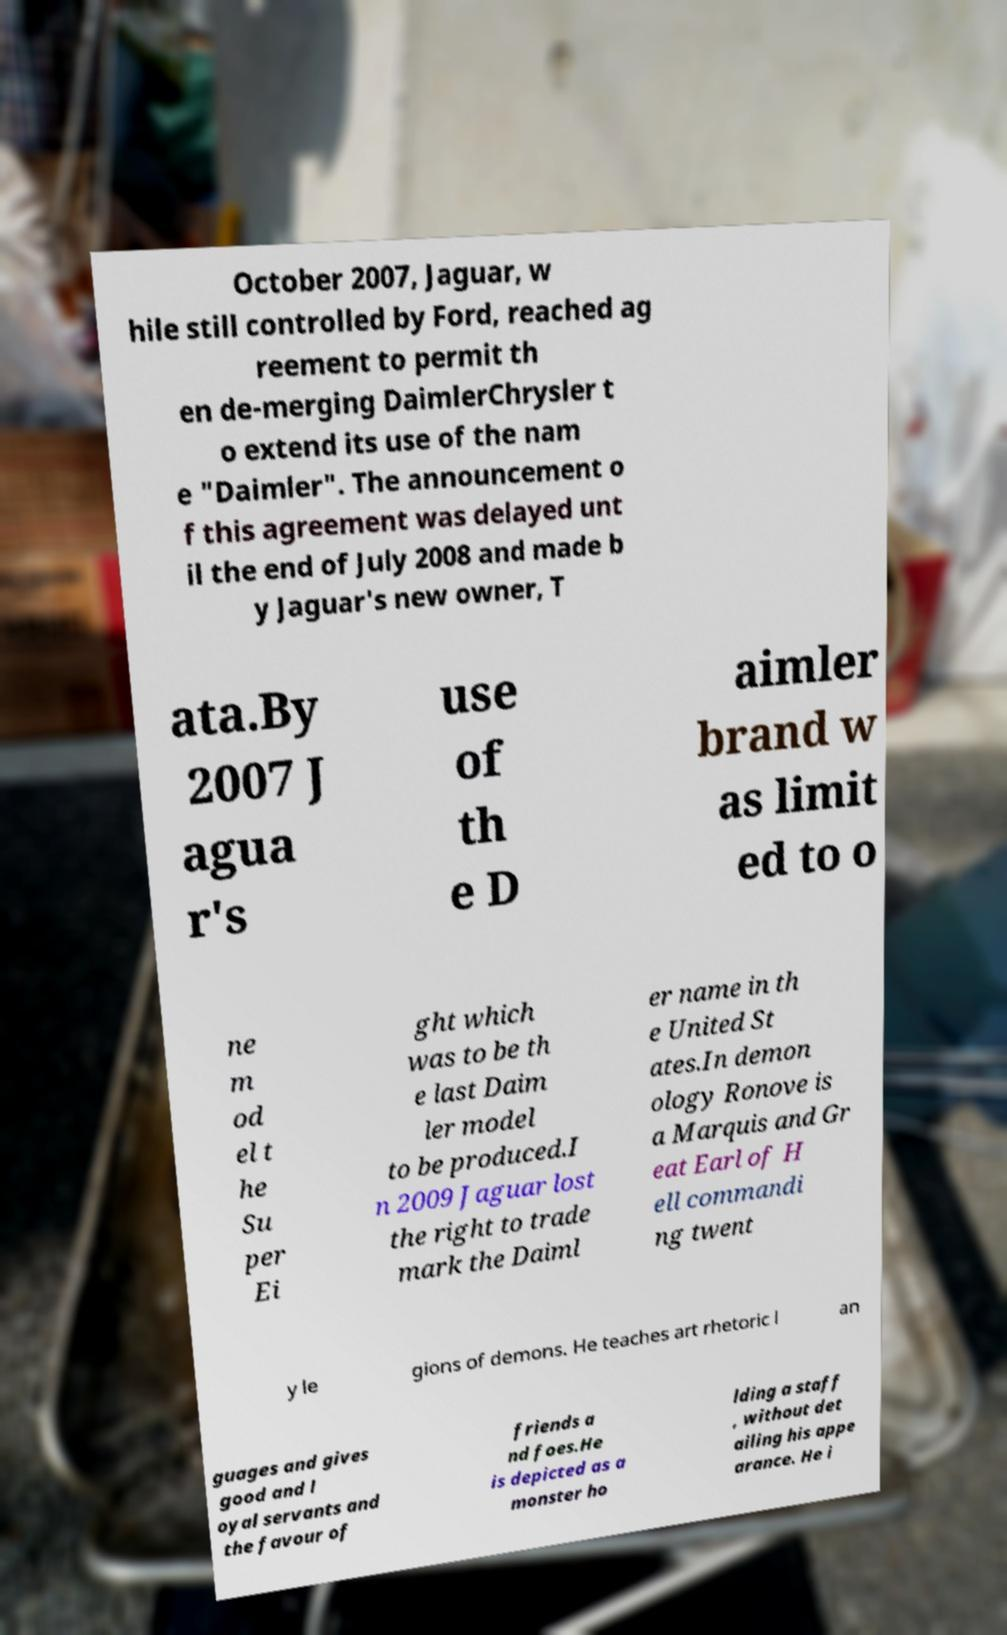Could you extract and type out the text from this image? October 2007, Jaguar, w hile still controlled by Ford, reached ag reement to permit th en de-merging DaimlerChrysler t o extend its use of the nam e "Daimler". The announcement o f this agreement was delayed unt il the end of July 2008 and made b y Jaguar's new owner, T ata.By 2007 J agua r's use of th e D aimler brand w as limit ed to o ne m od el t he Su per Ei ght which was to be th e last Daim ler model to be produced.I n 2009 Jaguar lost the right to trade mark the Daiml er name in th e United St ates.In demon ology Ronove is a Marquis and Gr eat Earl of H ell commandi ng twent y le gions of demons. He teaches art rhetoric l an guages and gives good and l oyal servants and the favour of friends a nd foes.He is depicted as a monster ho lding a staff , without det ailing his appe arance. He i 